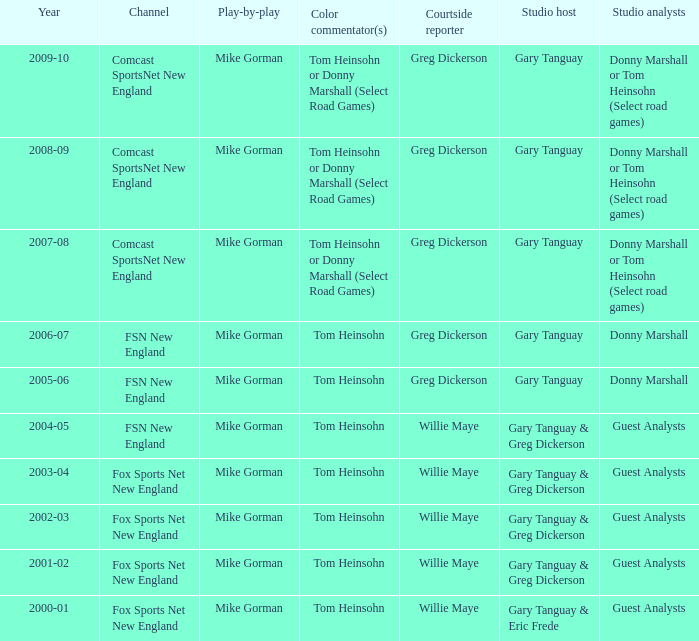WHich Studio host has a Year of 2003-04? Gary Tanguay & Greg Dickerson. 